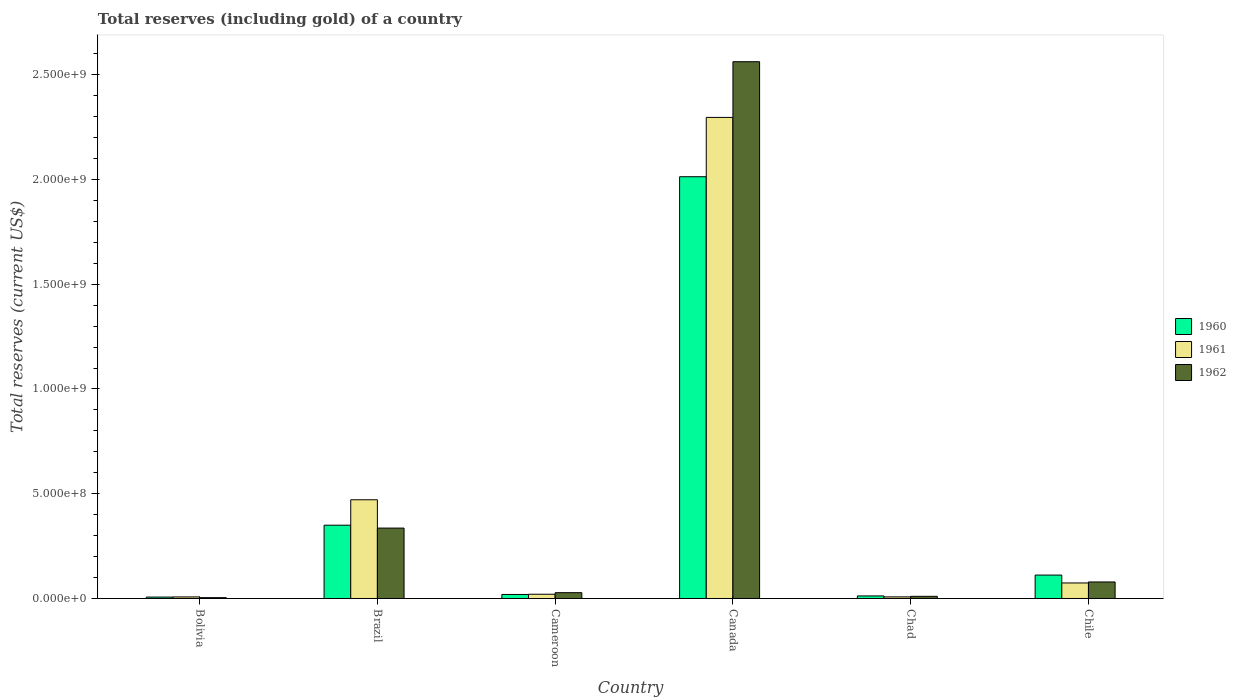How many different coloured bars are there?
Keep it short and to the point. 3. How many bars are there on the 3rd tick from the right?
Offer a very short reply. 3. What is the label of the 1st group of bars from the left?
Provide a succinct answer. Bolivia. In how many cases, is the number of bars for a given country not equal to the number of legend labels?
Your response must be concise. 0. What is the total reserves (including gold) in 1960 in Chile?
Make the answer very short. 1.12e+08. Across all countries, what is the maximum total reserves (including gold) in 1960?
Give a very brief answer. 2.01e+09. Across all countries, what is the minimum total reserves (including gold) in 1961?
Your answer should be very brief. 7.40e+06. In which country was the total reserves (including gold) in 1961 maximum?
Offer a terse response. Canada. What is the total total reserves (including gold) in 1960 in the graph?
Offer a terse response. 2.51e+09. What is the difference between the total reserves (including gold) in 1960 in Bolivia and that in Canada?
Your answer should be very brief. -2.01e+09. What is the difference between the total reserves (including gold) in 1960 in Canada and the total reserves (including gold) in 1961 in Chile?
Make the answer very short. 1.94e+09. What is the average total reserves (including gold) in 1961 per country?
Offer a terse response. 4.79e+08. What is the difference between the total reserves (including gold) of/in 1961 and total reserves (including gold) of/in 1960 in Brazil?
Your answer should be very brief. 1.21e+08. What is the ratio of the total reserves (including gold) in 1962 in Bolivia to that in Canada?
Ensure brevity in your answer.  0. Is the total reserves (including gold) in 1962 in Brazil less than that in Canada?
Your response must be concise. Yes. Is the difference between the total reserves (including gold) in 1961 in Cameroon and Chile greater than the difference between the total reserves (including gold) in 1960 in Cameroon and Chile?
Provide a short and direct response. Yes. What is the difference between the highest and the second highest total reserves (including gold) in 1962?
Offer a terse response. 2.23e+09. What is the difference between the highest and the lowest total reserves (including gold) in 1960?
Your answer should be compact. 2.01e+09. In how many countries, is the total reserves (including gold) in 1960 greater than the average total reserves (including gold) in 1960 taken over all countries?
Your answer should be compact. 1. Is the sum of the total reserves (including gold) in 1962 in Bolivia and Canada greater than the maximum total reserves (including gold) in 1961 across all countries?
Keep it short and to the point. Yes. Is it the case that in every country, the sum of the total reserves (including gold) in 1962 and total reserves (including gold) in 1961 is greater than the total reserves (including gold) in 1960?
Offer a very short reply. Yes. How many bars are there?
Ensure brevity in your answer.  18. Are all the bars in the graph horizontal?
Make the answer very short. No. How many countries are there in the graph?
Your response must be concise. 6. What is the difference between two consecutive major ticks on the Y-axis?
Provide a short and direct response. 5.00e+08. Are the values on the major ticks of Y-axis written in scientific E-notation?
Give a very brief answer. Yes. Does the graph contain grids?
Make the answer very short. No. What is the title of the graph?
Give a very brief answer. Total reserves (including gold) of a country. Does "1982" appear as one of the legend labels in the graph?
Offer a very short reply. No. What is the label or title of the Y-axis?
Keep it short and to the point. Total reserves (current US$). What is the Total reserves (current US$) of 1960 in Bolivia?
Your answer should be very brief. 6.72e+06. What is the Total reserves (current US$) of 1961 in Bolivia?
Ensure brevity in your answer.  7.40e+06. What is the Total reserves (current US$) in 1962 in Bolivia?
Make the answer very short. 4.01e+06. What is the Total reserves (current US$) of 1960 in Brazil?
Ensure brevity in your answer.  3.50e+08. What is the Total reserves (current US$) in 1961 in Brazil?
Ensure brevity in your answer.  4.71e+08. What is the Total reserves (current US$) of 1962 in Brazil?
Your answer should be very brief. 3.36e+08. What is the Total reserves (current US$) of 1960 in Cameroon?
Your response must be concise. 1.92e+07. What is the Total reserves (current US$) in 1961 in Cameroon?
Make the answer very short. 2.03e+07. What is the Total reserves (current US$) in 1962 in Cameroon?
Your answer should be very brief. 2.77e+07. What is the Total reserves (current US$) in 1960 in Canada?
Your response must be concise. 2.01e+09. What is the Total reserves (current US$) in 1961 in Canada?
Your answer should be very brief. 2.30e+09. What is the Total reserves (current US$) of 1962 in Canada?
Keep it short and to the point. 2.56e+09. What is the Total reserves (current US$) of 1960 in Chad?
Your response must be concise. 1.22e+07. What is the Total reserves (current US$) of 1961 in Chad?
Your answer should be very brief. 7.69e+06. What is the Total reserves (current US$) in 1962 in Chad?
Provide a succinct answer. 1.03e+07. What is the Total reserves (current US$) of 1960 in Chile?
Your answer should be compact. 1.12e+08. What is the Total reserves (current US$) of 1961 in Chile?
Ensure brevity in your answer.  7.41e+07. What is the Total reserves (current US$) in 1962 in Chile?
Offer a terse response. 7.89e+07. Across all countries, what is the maximum Total reserves (current US$) in 1960?
Provide a succinct answer. 2.01e+09. Across all countries, what is the maximum Total reserves (current US$) in 1961?
Your answer should be compact. 2.30e+09. Across all countries, what is the maximum Total reserves (current US$) of 1962?
Your response must be concise. 2.56e+09. Across all countries, what is the minimum Total reserves (current US$) in 1960?
Give a very brief answer. 6.72e+06. Across all countries, what is the minimum Total reserves (current US$) of 1961?
Offer a terse response. 7.40e+06. Across all countries, what is the minimum Total reserves (current US$) in 1962?
Keep it short and to the point. 4.01e+06. What is the total Total reserves (current US$) of 1960 in the graph?
Offer a very short reply. 2.51e+09. What is the total Total reserves (current US$) in 1961 in the graph?
Make the answer very short. 2.88e+09. What is the total Total reserves (current US$) in 1962 in the graph?
Provide a short and direct response. 3.02e+09. What is the difference between the Total reserves (current US$) of 1960 in Bolivia and that in Brazil?
Keep it short and to the point. -3.43e+08. What is the difference between the Total reserves (current US$) in 1961 in Bolivia and that in Brazil?
Your answer should be very brief. -4.64e+08. What is the difference between the Total reserves (current US$) of 1962 in Bolivia and that in Brazil?
Offer a very short reply. -3.32e+08. What is the difference between the Total reserves (current US$) in 1960 in Bolivia and that in Cameroon?
Offer a very short reply. -1.25e+07. What is the difference between the Total reserves (current US$) of 1961 in Bolivia and that in Cameroon?
Offer a very short reply. -1.29e+07. What is the difference between the Total reserves (current US$) of 1962 in Bolivia and that in Cameroon?
Make the answer very short. -2.37e+07. What is the difference between the Total reserves (current US$) in 1960 in Bolivia and that in Canada?
Provide a succinct answer. -2.01e+09. What is the difference between the Total reserves (current US$) in 1961 in Bolivia and that in Canada?
Offer a very short reply. -2.29e+09. What is the difference between the Total reserves (current US$) in 1962 in Bolivia and that in Canada?
Provide a short and direct response. -2.56e+09. What is the difference between the Total reserves (current US$) of 1960 in Bolivia and that in Chad?
Give a very brief answer. -5.52e+06. What is the difference between the Total reserves (current US$) in 1961 in Bolivia and that in Chad?
Offer a terse response. -2.86e+05. What is the difference between the Total reserves (current US$) of 1962 in Bolivia and that in Chad?
Offer a very short reply. -6.29e+06. What is the difference between the Total reserves (current US$) of 1960 in Bolivia and that in Chile?
Provide a short and direct response. -1.05e+08. What is the difference between the Total reserves (current US$) of 1961 in Bolivia and that in Chile?
Your answer should be very brief. -6.67e+07. What is the difference between the Total reserves (current US$) of 1962 in Bolivia and that in Chile?
Provide a succinct answer. -7.49e+07. What is the difference between the Total reserves (current US$) of 1960 in Brazil and that in Cameroon?
Offer a very short reply. 3.31e+08. What is the difference between the Total reserves (current US$) of 1961 in Brazil and that in Cameroon?
Provide a succinct answer. 4.51e+08. What is the difference between the Total reserves (current US$) of 1962 in Brazil and that in Cameroon?
Provide a succinct answer. 3.08e+08. What is the difference between the Total reserves (current US$) of 1960 in Brazil and that in Canada?
Ensure brevity in your answer.  -1.66e+09. What is the difference between the Total reserves (current US$) in 1961 in Brazil and that in Canada?
Provide a succinct answer. -1.82e+09. What is the difference between the Total reserves (current US$) of 1962 in Brazil and that in Canada?
Provide a short and direct response. -2.23e+09. What is the difference between the Total reserves (current US$) in 1960 in Brazil and that in Chad?
Give a very brief answer. 3.38e+08. What is the difference between the Total reserves (current US$) of 1961 in Brazil and that in Chad?
Your answer should be compact. 4.63e+08. What is the difference between the Total reserves (current US$) in 1962 in Brazil and that in Chad?
Make the answer very short. 3.26e+08. What is the difference between the Total reserves (current US$) in 1960 in Brazil and that in Chile?
Your response must be concise. 2.38e+08. What is the difference between the Total reserves (current US$) in 1961 in Brazil and that in Chile?
Make the answer very short. 3.97e+08. What is the difference between the Total reserves (current US$) of 1962 in Brazil and that in Chile?
Your answer should be compact. 2.57e+08. What is the difference between the Total reserves (current US$) of 1960 in Cameroon and that in Canada?
Offer a very short reply. -1.99e+09. What is the difference between the Total reserves (current US$) of 1961 in Cameroon and that in Canada?
Keep it short and to the point. -2.28e+09. What is the difference between the Total reserves (current US$) of 1962 in Cameroon and that in Canada?
Offer a very short reply. -2.53e+09. What is the difference between the Total reserves (current US$) of 1960 in Cameroon and that in Chad?
Your answer should be compact. 7.00e+06. What is the difference between the Total reserves (current US$) of 1961 in Cameroon and that in Chad?
Ensure brevity in your answer.  1.26e+07. What is the difference between the Total reserves (current US$) of 1962 in Cameroon and that in Chad?
Your answer should be compact. 1.74e+07. What is the difference between the Total reserves (current US$) of 1960 in Cameroon and that in Chile?
Give a very brief answer. -9.25e+07. What is the difference between the Total reserves (current US$) in 1961 in Cameroon and that in Chile?
Make the answer very short. -5.38e+07. What is the difference between the Total reserves (current US$) in 1962 in Cameroon and that in Chile?
Your answer should be compact. -5.12e+07. What is the difference between the Total reserves (current US$) in 1960 in Canada and that in Chad?
Offer a terse response. 2.00e+09. What is the difference between the Total reserves (current US$) in 1961 in Canada and that in Chad?
Provide a short and direct response. 2.29e+09. What is the difference between the Total reserves (current US$) of 1962 in Canada and that in Chad?
Offer a very short reply. 2.55e+09. What is the difference between the Total reserves (current US$) in 1960 in Canada and that in Chile?
Ensure brevity in your answer.  1.90e+09. What is the difference between the Total reserves (current US$) in 1961 in Canada and that in Chile?
Your response must be concise. 2.22e+09. What is the difference between the Total reserves (current US$) of 1962 in Canada and that in Chile?
Offer a terse response. 2.48e+09. What is the difference between the Total reserves (current US$) in 1960 in Chad and that in Chile?
Your response must be concise. -9.95e+07. What is the difference between the Total reserves (current US$) in 1961 in Chad and that in Chile?
Provide a succinct answer. -6.64e+07. What is the difference between the Total reserves (current US$) in 1962 in Chad and that in Chile?
Ensure brevity in your answer.  -6.86e+07. What is the difference between the Total reserves (current US$) in 1960 in Bolivia and the Total reserves (current US$) in 1961 in Brazil?
Your response must be concise. -4.64e+08. What is the difference between the Total reserves (current US$) in 1960 in Bolivia and the Total reserves (current US$) in 1962 in Brazil?
Keep it short and to the point. -3.29e+08. What is the difference between the Total reserves (current US$) of 1961 in Bolivia and the Total reserves (current US$) of 1962 in Brazil?
Give a very brief answer. -3.29e+08. What is the difference between the Total reserves (current US$) of 1960 in Bolivia and the Total reserves (current US$) of 1961 in Cameroon?
Offer a terse response. -1.36e+07. What is the difference between the Total reserves (current US$) in 1960 in Bolivia and the Total reserves (current US$) in 1962 in Cameroon?
Keep it short and to the point. -2.10e+07. What is the difference between the Total reserves (current US$) of 1961 in Bolivia and the Total reserves (current US$) of 1962 in Cameroon?
Your answer should be compact. -2.03e+07. What is the difference between the Total reserves (current US$) of 1960 in Bolivia and the Total reserves (current US$) of 1961 in Canada?
Offer a terse response. -2.29e+09. What is the difference between the Total reserves (current US$) of 1960 in Bolivia and the Total reserves (current US$) of 1962 in Canada?
Provide a succinct answer. -2.56e+09. What is the difference between the Total reserves (current US$) in 1961 in Bolivia and the Total reserves (current US$) in 1962 in Canada?
Offer a terse response. -2.55e+09. What is the difference between the Total reserves (current US$) of 1960 in Bolivia and the Total reserves (current US$) of 1961 in Chad?
Keep it short and to the point. -9.75e+05. What is the difference between the Total reserves (current US$) in 1960 in Bolivia and the Total reserves (current US$) in 1962 in Chad?
Ensure brevity in your answer.  -3.58e+06. What is the difference between the Total reserves (current US$) in 1961 in Bolivia and the Total reserves (current US$) in 1962 in Chad?
Offer a very short reply. -2.90e+06. What is the difference between the Total reserves (current US$) in 1960 in Bolivia and the Total reserves (current US$) in 1961 in Chile?
Offer a terse response. -6.74e+07. What is the difference between the Total reserves (current US$) in 1960 in Bolivia and the Total reserves (current US$) in 1962 in Chile?
Make the answer very short. -7.22e+07. What is the difference between the Total reserves (current US$) in 1961 in Bolivia and the Total reserves (current US$) in 1962 in Chile?
Ensure brevity in your answer.  -7.15e+07. What is the difference between the Total reserves (current US$) in 1960 in Brazil and the Total reserves (current US$) in 1961 in Cameroon?
Offer a very short reply. 3.30e+08. What is the difference between the Total reserves (current US$) of 1960 in Brazil and the Total reserves (current US$) of 1962 in Cameroon?
Make the answer very short. 3.22e+08. What is the difference between the Total reserves (current US$) of 1961 in Brazil and the Total reserves (current US$) of 1962 in Cameroon?
Provide a succinct answer. 4.43e+08. What is the difference between the Total reserves (current US$) in 1960 in Brazil and the Total reserves (current US$) in 1961 in Canada?
Ensure brevity in your answer.  -1.95e+09. What is the difference between the Total reserves (current US$) in 1960 in Brazil and the Total reserves (current US$) in 1962 in Canada?
Make the answer very short. -2.21e+09. What is the difference between the Total reserves (current US$) in 1961 in Brazil and the Total reserves (current US$) in 1962 in Canada?
Offer a very short reply. -2.09e+09. What is the difference between the Total reserves (current US$) of 1960 in Brazil and the Total reserves (current US$) of 1961 in Chad?
Ensure brevity in your answer.  3.42e+08. What is the difference between the Total reserves (current US$) of 1960 in Brazil and the Total reserves (current US$) of 1962 in Chad?
Offer a very short reply. 3.40e+08. What is the difference between the Total reserves (current US$) of 1961 in Brazil and the Total reserves (current US$) of 1962 in Chad?
Provide a short and direct response. 4.61e+08. What is the difference between the Total reserves (current US$) in 1960 in Brazil and the Total reserves (current US$) in 1961 in Chile?
Your answer should be compact. 2.76e+08. What is the difference between the Total reserves (current US$) in 1960 in Brazil and the Total reserves (current US$) in 1962 in Chile?
Make the answer very short. 2.71e+08. What is the difference between the Total reserves (current US$) in 1961 in Brazil and the Total reserves (current US$) in 1962 in Chile?
Your answer should be very brief. 3.92e+08. What is the difference between the Total reserves (current US$) of 1960 in Cameroon and the Total reserves (current US$) of 1961 in Canada?
Your response must be concise. -2.28e+09. What is the difference between the Total reserves (current US$) of 1960 in Cameroon and the Total reserves (current US$) of 1962 in Canada?
Your answer should be very brief. -2.54e+09. What is the difference between the Total reserves (current US$) in 1961 in Cameroon and the Total reserves (current US$) in 1962 in Canada?
Give a very brief answer. -2.54e+09. What is the difference between the Total reserves (current US$) of 1960 in Cameroon and the Total reserves (current US$) of 1961 in Chad?
Keep it short and to the point. 1.16e+07. What is the difference between the Total reserves (current US$) of 1960 in Cameroon and the Total reserves (current US$) of 1962 in Chad?
Provide a succinct answer. 8.94e+06. What is the difference between the Total reserves (current US$) of 1961 in Cameroon and the Total reserves (current US$) of 1962 in Chad?
Provide a short and direct response. 1.00e+07. What is the difference between the Total reserves (current US$) in 1960 in Cameroon and the Total reserves (current US$) in 1961 in Chile?
Your response must be concise. -5.49e+07. What is the difference between the Total reserves (current US$) of 1960 in Cameroon and the Total reserves (current US$) of 1962 in Chile?
Keep it short and to the point. -5.97e+07. What is the difference between the Total reserves (current US$) of 1961 in Cameroon and the Total reserves (current US$) of 1962 in Chile?
Ensure brevity in your answer.  -5.86e+07. What is the difference between the Total reserves (current US$) of 1960 in Canada and the Total reserves (current US$) of 1961 in Chad?
Make the answer very short. 2.01e+09. What is the difference between the Total reserves (current US$) in 1960 in Canada and the Total reserves (current US$) in 1962 in Chad?
Give a very brief answer. 2.00e+09. What is the difference between the Total reserves (current US$) in 1961 in Canada and the Total reserves (current US$) in 1962 in Chad?
Offer a very short reply. 2.29e+09. What is the difference between the Total reserves (current US$) in 1960 in Canada and the Total reserves (current US$) in 1961 in Chile?
Your answer should be very brief. 1.94e+09. What is the difference between the Total reserves (current US$) in 1960 in Canada and the Total reserves (current US$) in 1962 in Chile?
Offer a terse response. 1.93e+09. What is the difference between the Total reserves (current US$) in 1961 in Canada and the Total reserves (current US$) in 1962 in Chile?
Your answer should be compact. 2.22e+09. What is the difference between the Total reserves (current US$) in 1960 in Chad and the Total reserves (current US$) in 1961 in Chile?
Your response must be concise. -6.19e+07. What is the difference between the Total reserves (current US$) in 1960 in Chad and the Total reserves (current US$) in 1962 in Chile?
Your answer should be very brief. -6.67e+07. What is the difference between the Total reserves (current US$) of 1961 in Chad and the Total reserves (current US$) of 1962 in Chile?
Offer a terse response. -7.12e+07. What is the average Total reserves (current US$) of 1960 per country?
Make the answer very short. 4.19e+08. What is the average Total reserves (current US$) in 1961 per country?
Provide a succinct answer. 4.79e+08. What is the average Total reserves (current US$) in 1962 per country?
Give a very brief answer. 5.03e+08. What is the difference between the Total reserves (current US$) of 1960 and Total reserves (current US$) of 1961 in Bolivia?
Your answer should be compact. -6.89e+05. What is the difference between the Total reserves (current US$) in 1960 and Total reserves (current US$) in 1962 in Bolivia?
Give a very brief answer. 2.71e+06. What is the difference between the Total reserves (current US$) of 1961 and Total reserves (current US$) of 1962 in Bolivia?
Keep it short and to the point. 3.40e+06. What is the difference between the Total reserves (current US$) in 1960 and Total reserves (current US$) in 1961 in Brazil?
Provide a succinct answer. -1.21e+08. What is the difference between the Total reserves (current US$) of 1960 and Total reserves (current US$) of 1962 in Brazil?
Keep it short and to the point. 1.38e+07. What is the difference between the Total reserves (current US$) in 1961 and Total reserves (current US$) in 1962 in Brazil?
Make the answer very short. 1.35e+08. What is the difference between the Total reserves (current US$) of 1960 and Total reserves (current US$) of 1961 in Cameroon?
Provide a succinct answer. -1.06e+06. What is the difference between the Total reserves (current US$) of 1960 and Total reserves (current US$) of 1962 in Cameroon?
Ensure brevity in your answer.  -8.47e+06. What is the difference between the Total reserves (current US$) in 1961 and Total reserves (current US$) in 1962 in Cameroon?
Provide a succinct answer. -7.41e+06. What is the difference between the Total reserves (current US$) of 1960 and Total reserves (current US$) of 1961 in Canada?
Ensure brevity in your answer.  -2.83e+08. What is the difference between the Total reserves (current US$) of 1960 and Total reserves (current US$) of 1962 in Canada?
Offer a terse response. -5.49e+08. What is the difference between the Total reserves (current US$) in 1961 and Total reserves (current US$) in 1962 in Canada?
Your answer should be very brief. -2.66e+08. What is the difference between the Total reserves (current US$) in 1960 and Total reserves (current US$) in 1961 in Chad?
Keep it short and to the point. 4.55e+06. What is the difference between the Total reserves (current US$) in 1960 and Total reserves (current US$) in 1962 in Chad?
Provide a short and direct response. 1.94e+06. What is the difference between the Total reserves (current US$) in 1961 and Total reserves (current US$) in 1962 in Chad?
Give a very brief answer. -2.61e+06. What is the difference between the Total reserves (current US$) of 1960 and Total reserves (current US$) of 1961 in Chile?
Make the answer very short. 3.77e+07. What is the difference between the Total reserves (current US$) in 1960 and Total reserves (current US$) in 1962 in Chile?
Your answer should be compact. 3.29e+07. What is the difference between the Total reserves (current US$) in 1961 and Total reserves (current US$) in 1962 in Chile?
Your response must be concise. -4.78e+06. What is the ratio of the Total reserves (current US$) in 1960 in Bolivia to that in Brazil?
Your response must be concise. 0.02. What is the ratio of the Total reserves (current US$) of 1961 in Bolivia to that in Brazil?
Your answer should be compact. 0.02. What is the ratio of the Total reserves (current US$) in 1962 in Bolivia to that in Brazil?
Make the answer very short. 0.01. What is the ratio of the Total reserves (current US$) of 1960 in Bolivia to that in Cameroon?
Keep it short and to the point. 0.35. What is the ratio of the Total reserves (current US$) of 1961 in Bolivia to that in Cameroon?
Your answer should be very brief. 0.36. What is the ratio of the Total reserves (current US$) in 1962 in Bolivia to that in Cameroon?
Offer a very short reply. 0.14. What is the ratio of the Total reserves (current US$) in 1960 in Bolivia to that in Canada?
Make the answer very short. 0. What is the ratio of the Total reserves (current US$) in 1961 in Bolivia to that in Canada?
Your response must be concise. 0. What is the ratio of the Total reserves (current US$) of 1962 in Bolivia to that in Canada?
Provide a succinct answer. 0. What is the ratio of the Total reserves (current US$) of 1960 in Bolivia to that in Chad?
Offer a terse response. 0.55. What is the ratio of the Total reserves (current US$) of 1961 in Bolivia to that in Chad?
Your answer should be compact. 0.96. What is the ratio of the Total reserves (current US$) of 1962 in Bolivia to that in Chad?
Provide a short and direct response. 0.39. What is the ratio of the Total reserves (current US$) in 1960 in Bolivia to that in Chile?
Ensure brevity in your answer.  0.06. What is the ratio of the Total reserves (current US$) in 1961 in Bolivia to that in Chile?
Offer a very short reply. 0.1. What is the ratio of the Total reserves (current US$) of 1962 in Bolivia to that in Chile?
Your answer should be very brief. 0.05. What is the ratio of the Total reserves (current US$) of 1960 in Brazil to that in Cameroon?
Provide a short and direct response. 18.18. What is the ratio of the Total reserves (current US$) of 1961 in Brazil to that in Cameroon?
Offer a terse response. 23.21. What is the ratio of the Total reserves (current US$) in 1962 in Brazil to that in Cameroon?
Your answer should be very brief. 12.13. What is the ratio of the Total reserves (current US$) of 1960 in Brazil to that in Canada?
Your answer should be very brief. 0.17. What is the ratio of the Total reserves (current US$) in 1961 in Brazil to that in Canada?
Your answer should be compact. 0.21. What is the ratio of the Total reserves (current US$) of 1962 in Brazil to that in Canada?
Provide a short and direct response. 0.13. What is the ratio of the Total reserves (current US$) of 1960 in Brazil to that in Chad?
Your answer should be very brief. 28.58. What is the ratio of the Total reserves (current US$) of 1961 in Brazil to that in Chad?
Ensure brevity in your answer.  61.27. What is the ratio of the Total reserves (current US$) in 1962 in Brazil to that in Chad?
Provide a short and direct response. 32.62. What is the ratio of the Total reserves (current US$) of 1960 in Brazil to that in Chile?
Offer a terse response. 3.13. What is the ratio of the Total reserves (current US$) in 1961 in Brazil to that in Chile?
Make the answer very short. 6.36. What is the ratio of the Total reserves (current US$) of 1962 in Brazil to that in Chile?
Ensure brevity in your answer.  4.26. What is the ratio of the Total reserves (current US$) of 1960 in Cameroon to that in Canada?
Keep it short and to the point. 0.01. What is the ratio of the Total reserves (current US$) of 1961 in Cameroon to that in Canada?
Your response must be concise. 0.01. What is the ratio of the Total reserves (current US$) in 1962 in Cameroon to that in Canada?
Offer a very short reply. 0.01. What is the ratio of the Total reserves (current US$) of 1960 in Cameroon to that in Chad?
Your response must be concise. 1.57. What is the ratio of the Total reserves (current US$) of 1961 in Cameroon to that in Chad?
Offer a terse response. 2.64. What is the ratio of the Total reserves (current US$) of 1962 in Cameroon to that in Chad?
Your answer should be very brief. 2.69. What is the ratio of the Total reserves (current US$) of 1960 in Cameroon to that in Chile?
Give a very brief answer. 0.17. What is the ratio of the Total reserves (current US$) in 1961 in Cameroon to that in Chile?
Offer a very short reply. 0.27. What is the ratio of the Total reserves (current US$) of 1962 in Cameroon to that in Chile?
Your answer should be compact. 0.35. What is the ratio of the Total reserves (current US$) in 1960 in Canada to that in Chad?
Offer a terse response. 164.46. What is the ratio of the Total reserves (current US$) of 1961 in Canada to that in Chad?
Provide a short and direct response. 298.58. What is the ratio of the Total reserves (current US$) in 1962 in Canada to that in Chad?
Offer a terse response. 248.73. What is the ratio of the Total reserves (current US$) of 1960 in Canada to that in Chile?
Offer a very short reply. 18.01. What is the ratio of the Total reserves (current US$) in 1961 in Canada to that in Chile?
Provide a short and direct response. 30.98. What is the ratio of the Total reserves (current US$) in 1962 in Canada to that in Chile?
Give a very brief answer. 32.47. What is the ratio of the Total reserves (current US$) in 1960 in Chad to that in Chile?
Give a very brief answer. 0.11. What is the ratio of the Total reserves (current US$) of 1961 in Chad to that in Chile?
Provide a short and direct response. 0.1. What is the ratio of the Total reserves (current US$) in 1962 in Chad to that in Chile?
Ensure brevity in your answer.  0.13. What is the difference between the highest and the second highest Total reserves (current US$) in 1960?
Provide a short and direct response. 1.66e+09. What is the difference between the highest and the second highest Total reserves (current US$) in 1961?
Your answer should be compact. 1.82e+09. What is the difference between the highest and the second highest Total reserves (current US$) in 1962?
Your answer should be very brief. 2.23e+09. What is the difference between the highest and the lowest Total reserves (current US$) in 1960?
Your answer should be compact. 2.01e+09. What is the difference between the highest and the lowest Total reserves (current US$) in 1961?
Keep it short and to the point. 2.29e+09. What is the difference between the highest and the lowest Total reserves (current US$) of 1962?
Your answer should be compact. 2.56e+09. 